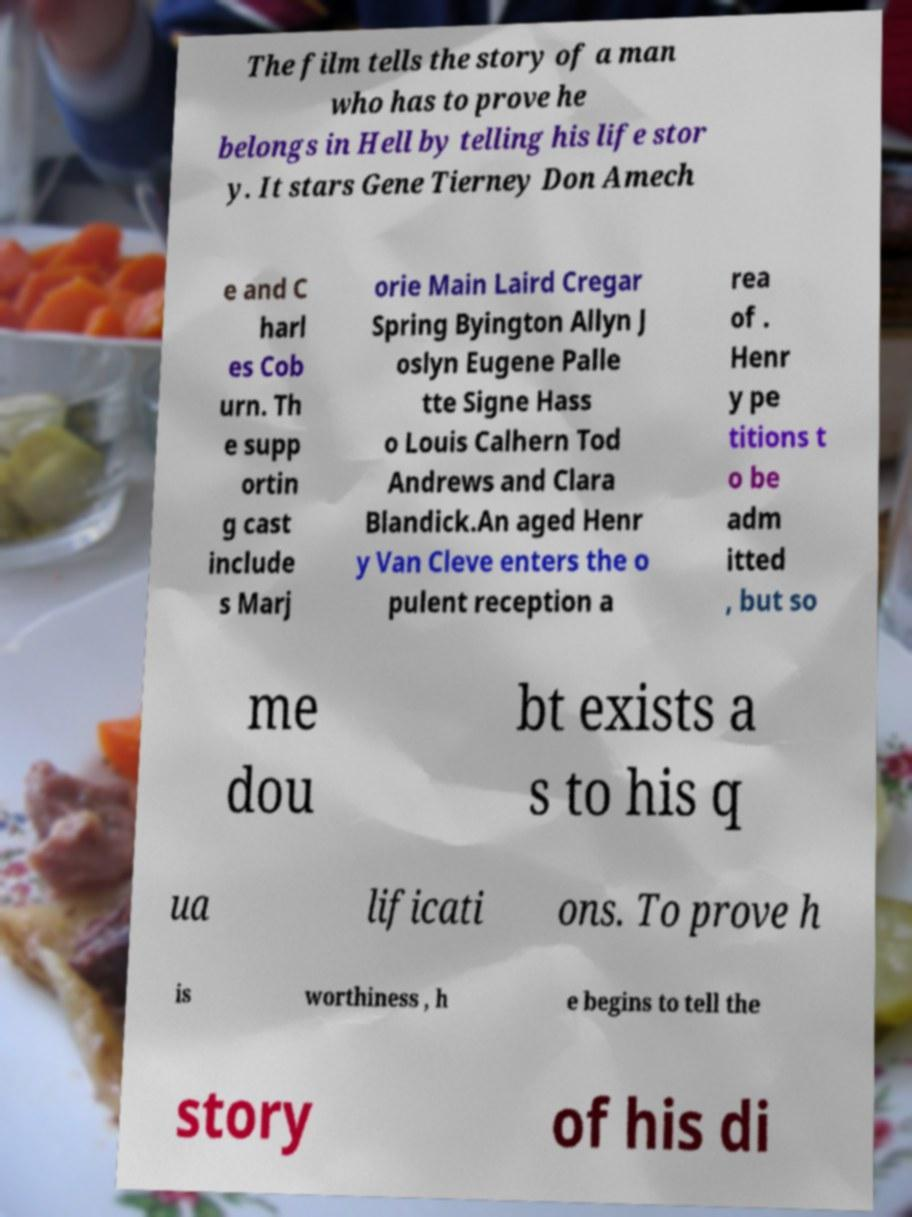Please identify and transcribe the text found in this image. The film tells the story of a man who has to prove he belongs in Hell by telling his life stor y. It stars Gene Tierney Don Amech e and C harl es Cob urn. Th e supp ortin g cast include s Marj orie Main Laird Cregar Spring Byington Allyn J oslyn Eugene Palle tte Signe Hass o Louis Calhern Tod Andrews and Clara Blandick.An aged Henr y Van Cleve enters the o pulent reception a rea of . Henr y pe titions t o be adm itted , but so me dou bt exists a s to his q ua lificati ons. To prove h is worthiness , h e begins to tell the story of his di 